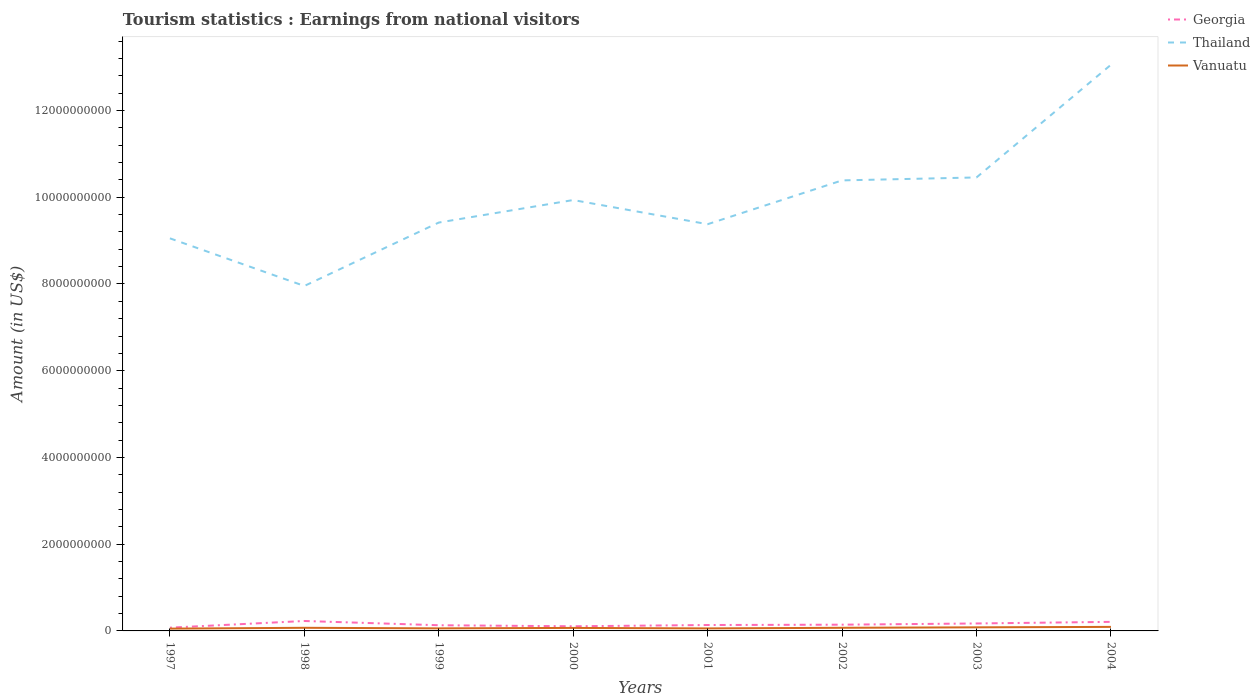How many different coloured lines are there?
Provide a succinct answer. 3. Across all years, what is the maximum earnings from national visitors in Thailand?
Provide a short and direct response. 7.95e+09. In which year was the earnings from national visitors in Vanuatu maximum?
Your answer should be very brief. 1997. What is the total earnings from national visitors in Georgia in the graph?
Your answer should be compact. -8.00e+06. What is the difference between the highest and the second highest earnings from national visitors in Georgia?
Make the answer very short. 1.54e+08. What is the difference between the highest and the lowest earnings from national visitors in Georgia?
Provide a succinct answer. 3. How many lines are there?
Provide a succinct answer. 3. How many years are there in the graph?
Provide a short and direct response. 8. Does the graph contain any zero values?
Ensure brevity in your answer.  No. Where does the legend appear in the graph?
Make the answer very short. Top right. How are the legend labels stacked?
Your response must be concise. Vertical. What is the title of the graph?
Your answer should be very brief. Tourism statistics : Earnings from national visitors. Does "Djibouti" appear as one of the legend labels in the graph?
Ensure brevity in your answer.  No. What is the Amount (in US$) of Georgia in 1997?
Offer a terse response. 7.50e+07. What is the Amount (in US$) of Thailand in 1997?
Your answer should be very brief. 9.05e+09. What is the Amount (in US$) of Vanuatu in 1997?
Offer a very short reply. 5.30e+07. What is the Amount (in US$) of Georgia in 1998?
Your response must be concise. 2.29e+08. What is the Amount (in US$) in Thailand in 1998?
Your answer should be very brief. 7.95e+09. What is the Amount (in US$) in Vanuatu in 1998?
Ensure brevity in your answer.  7.20e+07. What is the Amount (in US$) in Georgia in 1999?
Your answer should be compact. 1.31e+08. What is the Amount (in US$) of Thailand in 1999?
Offer a very short reply. 9.42e+09. What is the Amount (in US$) of Vanuatu in 1999?
Give a very brief answer. 5.90e+07. What is the Amount (in US$) in Georgia in 2000?
Provide a short and direct response. 1.07e+08. What is the Amount (in US$) of Thailand in 2000?
Make the answer very short. 9.94e+09. What is the Amount (in US$) in Vanuatu in 2000?
Your response must be concise. 6.90e+07. What is the Amount (in US$) of Georgia in 2001?
Offer a terse response. 1.36e+08. What is the Amount (in US$) of Thailand in 2001?
Keep it short and to the point. 9.38e+09. What is the Amount (in US$) of Vanuatu in 2001?
Give a very brief answer. 5.80e+07. What is the Amount (in US$) in Georgia in 2002?
Ensure brevity in your answer.  1.44e+08. What is the Amount (in US$) of Thailand in 2002?
Your answer should be compact. 1.04e+1. What is the Amount (in US$) in Vanuatu in 2002?
Your answer should be compact. 7.20e+07. What is the Amount (in US$) in Georgia in 2003?
Provide a succinct answer. 1.72e+08. What is the Amount (in US$) in Thailand in 2003?
Give a very brief answer. 1.05e+1. What is the Amount (in US$) in Vanuatu in 2003?
Provide a short and direct response. 8.30e+07. What is the Amount (in US$) of Georgia in 2004?
Provide a succinct answer. 2.09e+08. What is the Amount (in US$) in Thailand in 2004?
Your answer should be compact. 1.31e+1. What is the Amount (in US$) of Vanuatu in 2004?
Your answer should be very brief. 9.30e+07. Across all years, what is the maximum Amount (in US$) of Georgia?
Provide a succinct answer. 2.29e+08. Across all years, what is the maximum Amount (in US$) in Thailand?
Give a very brief answer. 1.31e+1. Across all years, what is the maximum Amount (in US$) in Vanuatu?
Offer a very short reply. 9.30e+07. Across all years, what is the minimum Amount (in US$) of Georgia?
Ensure brevity in your answer.  7.50e+07. Across all years, what is the minimum Amount (in US$) in Thailand?
Keep it short and to the point. 7.95e+09. Across all years, what is the minimum Amount (in US$) in Vanuatu?
Your answer should be compact. 5.30e+07. What is the total Amount (in US$) of Georgia in the graph?
Give a very brief answer. 1.20e+09. What is the total Amount (in US$) in Thailand in the graph?
Give a very brief answer. 7.96e+1. What is the total Amount (in US$) in Vanuatu in the graph?
Make the answer very short. 5.59e+08. What is the difference between the Amount (in US$) in Georgia in 1997 and that in 1998?
Make the answer very short. -1.54e+08. What is the difference between the Amount (in US$) in Thailand in 1997 and that in 1998?
Your answer should be very brief. 1.10e+09. What is the difference between the Amount (in US$) in Vanuatu in 1997 and that in 1998?
Your response must be concise. -1.90e+07. What is the difference between the Amount (in US$) in Georgia in 1997 and that in 1999?
Your response must be concise. -5.60e+07. What is the difference between the Amount (in US$) of Thailand in 1997 and that in 1999?
Provide a succinct answer. -3.64e+08. What is the difference between the Amount (in US$) of Vanuatu in 1997 and that in 1999?
Keep it short and to the point. -6.00e+06. What is the difference between the Amount (in US$) in Georgia in 1997 and that in 2000?
Offer a very short reply. -3.20e+07. What is the difference between the Amount (in US$) in Thailand in 1997 and that in 2000?
Ensure brevity in your answer.  -8.83e+08. What is the difference between the Amount (in US$) of Vanuatu in 1997 and that in 2000?
Offer a terse response. -1.60e+07. What is the difference between the Amount (in US$) of Georgia in 1997 and that in 2001?
Provide a short and direct response. -6.10e+07. What is the difference between the Amount (in US$) of Thailand in 1997 and that in 2001?
Provide a short and direct response. -3.26e+08. What is the difference between the Amount (in US$) in Vanuatu in 1997 and that in 2001?
Your answer should be very brief. -5.00e+06. What is the difference between the Amount (in US$) in Georgia in 1997 and that in 2002?
Your answer should be compact. -6.90e+07. What is the difference between the Amount (in US$) of Thailand in 1997 and that in 2002?
Your answer should be compact. -1.34e+09. What is the difference between the Amount (in US$) of Vanuatu in 1997 and that in 2002?
Your response must be concise. -1.90e+07. What is the difference between the Amount (in US$) in Georgia in 1997 and that in 2003?
Your answer should be compact. -9.70e+07. What is the difference between the Amount (in US$) of Thailand in 1997 and that in 2003?
Provide a succinct answer. -1.40e+09. What is the difference between the Amount (in US$) of Vanuatu in 1997 and that in 2003?
Offer a terse response. -3.00e+07. What is the difference between the Amount (in US$) of Georgia in 1997 and that in 2004?
Your response must be concise. -1.34e+08. What is the difference between the Amount (in US$) of Thailand in 1997 and that in 2004?
Your answer should be very brief. -4.00e+09. What is the difference between the Amount (in US$) in Vanuatu in 1997 and that in 2004?
Provide a short and direct response. -4.00e+07. What is the difference between the Amount (in US$) in Georgia in 1998 and that in 1999?
Your answer should be very brief. 9.80e+07. What is the difference between the Amount (in US$) in Thailand in 1998 and that in 1999?
Ensure brevity in your answer.  -1.46e+09. What is the difference between the Amount (in US$) in Vanuatu in 1998 and that in 1999?
Your answer should be very brief. 1.30e+07. What is the difference between the Amount (in US$) in Georgia in 1998 and that in 2000?
Provide a short and direct response. 1.22e+08. What is the difference between the Amount (in US$) of Thailand in 1998 and that in 2000?
Offer a very short reply. -1.98e+09. What is the difference between the Amount (in US$) of Georgia in 1998 and that in 2001?
Offer a very short reply. 9.30e+07. What is the difference between the Amount (in US$) in Thailand in 1998 and that in 2001?
Make the answer very short. -1.42e+09. What is the difference between the Amount (in US$) of Vanuatu in 1998 and that in 2001?
Give a very brief answer. 1.40e+07. What is the difference between the Amount (in US$) of Georgia in 1998 and that in 2002?
Your response must be concise. 8.50e+07. What is the difference between the Amount (in US$) of Thailand in 1998 and that in 2002?
Keep it short and to the point. -2.43e+09. What is the difference between the Amount (in US$) of Georgia in 1998 and that in 2003?
Offer a terse response. 5.70e+07. What is the difference between the Amount (in US$) of Thailand in 1998 and that in 2003?
Make the answer very short. -2.50e+09. What is the difference between the Amount (in US$) of Vanuatu in 1998 and that in 2003?
Your answer should be compact. -1.10e+07. What is the difference between the Amount (in US$) in Georgia in 1998 and that in 2004?
Provide a succinct answer. 2.00e+07. What is the difference between the Amount (in US$) in Thailand in 1998 and that in 2004?
Your answer should be compact. -5.10e+09. What is the difference between the Amount (in US$) of Vanuatu in 1998 and that in 2004?
Provide a short and direct response. -2.10e+07. What is the difference between the Amount (in US$) of Georgia in 1999 and that in 2000?
Offer a very short reply. 2.40e+07. What is the difference between the Amount (in US$) of Thailand in 1999 and that in 2000?
Give a very brief answer. -5.19e+08. What is the difference between the Amount (in US$) in Vanuatu in 1999 and that in 2000?
Offer a terse response. -1.00e+07. What is the difference between the Amount (in US$) of Georgia in 1999 and that in 2001?
Your answer should be compact. -5.00e+06. What is the difference between the Amount (in US$) in Thailand in 1999 and that in 2001?
Your response must be concise. 3.80e+07. What is the difference between the Amount (in US$) of Georgia in 1999 and that in 2002?
Give a very brief answer. -1.30e+07. What is the difference between the Amount (in US$) of Thailand in 1999 and that in 2002?
Keep it short and to the point. -9.72e+08. What is the difference between the Amount (in US$) of Vanuatu in 1999 and that in 2002?
Give a very brief answer. -1.30e+07. What is the difference between the Amount (in US$) of Georgia in 1999 and that in 2003?
Keep it short and to the point. -4.10e+07. What is the difference between the Amount (in US$) of Thailand in 1999 and that in 2003?
Make the answer very short. -1.04e+09. What is the difference between the Amount (in US$) of Vanuatu in 1999 and that in 2003?
Give a very brief answer. -2.40e+07. What is the difference between the Amount (in US$) of Georgia in 1999 and that in 2004?
Give a very brief answer. -7.80e+07. What is the difference between the Amount (in US$) in Thailand in 1999 and that in 2004?
Give a very brief answer. -3.64e+09. What is the difference between the Amount (in US$) in Vanuatu in 1999 and that in 2004?
Provide a short and direct response. -3.40e+07. What is the difference between the Amount (in US$) in Georgia in 2000 and that in 2001?
Offer a terse response. -2.90e+07. What is the difference between the Amount (in US$) of Thailand in 2000 and that in 2001?
Ensure brevity in your answer.  5.57e+08. What is the difference between the Amount (in US$) of Vanuatu in 2000 and that in 2001?
Your answer should be compact. 1.10e+07. What is the difference between the Amount (in US$) in Georgia in 2000 and that in 2002?
Provide a succinct answer. -3.70e+07. What is the difference between the Amount (in US$) of Thailand in 2000 and that in 2002?
Keep it short and to the point. -4.53e+08. What is the difference between the Amount (in US$) of Vanuatu in 2000 and that in 2002?
Your answer should be very brief. -3.00e+06. What is the difference between the Amount (in US$) in Georgia in 2000 and that in 2003?
Provide a succinct answer. -6.50e+07. What is the difference between the Amount (in US$) in Thailand in 2000 and that in 2003?
Your answer should be compact. -5.21e+08. What is the difference between the Amount (in US$) of Vanuatu in 2000 and that in 2003?
Your response must be concise. -1.40e+07. What is the difference between the Amount (in US$) of Georgia in 2000 and that in 2004?
Keep it short and to the point. -1.02e+08. What is the difference between the Amount (in US$) in Thailand in 2000 and that in 2004?
Keep it short and to the point. -3.12e+09. What is the difference between the Amount (in US$) of Vanuatu in 2000 and that in 2004?
Offer a terse response. -2.40e+07. What is the difference between the Amount (in US$) in Georgia in 2001 and that in 2002?
Offer a very short reply. -8.00e+06. What is the difference between the Amount (in US$) of Thailand in 2001 and that in 2002?
Your answer should be compact. -1.01e+09. What is the difference between the Amount (in US$) of Vanuatu in 2001 and that in 2002?
Ensure brevity in your answer.  -1.40e+07. What is the difference between the Amount (in US$) in Georgia in 2001 and that in 2003?
Offer a terse response. -3.60e+07. What is the difference between the Amount (in US$) in Thailand in 2001 and that in 2003?
Give a very brief answer. -1.08e+09. What is the difference between the Amount (in US$) in Vanuatu in 2001 and that in 2003?
Ensure brevity in your answer.  -2.50e+07. What is the difference between the Amount (in US$) in Georgia in 2001 and that in 2004?
Ensure brevity in your answer.  -7.30e+07. What is the difference between the Amount (in US$) of Thailand in 2001 and that in 2004?
Keep it short and to the point. -3.68e+09. What is the difference between the Amount (in US$) in Vanuatu in 2001 and that in 2004?
Make the answer very short. -3.50e+07. What is the difference between the Amount (in US$) in Georgia in 2002 and that in 2003?
Offer a very short reply. -2.80e+07. What is the difference between the Amount (in US$) in Thailand in 2002 and that in 2003?
Give a very brief answer. -6.80e+07. What is the difference between the Amount (in US$) in Vanuatu in 2002 and that in 2003?
Keep it short and to the point. -1.10e+07. What is the difference between the Amount (in US$) in Georgia in 2002 and that in 2004?
Provide a short and direct response. -6.50e+07. What is the difference between the Amount (in US$) in Thailand in 2002 and that in 2004?
Give a very brief answer. -2.67e+09. What is the difference between the Amount (in US$) in Vanuatu in 2002 and that in 2004?
Ensure brevity in your answer.  -2.10e+07. What is the difference between the Amount (in US$) of Georgia in 2003 and that in 2004?
Your answer should be very brief. -3.70e+07. What is the difference between the Amount (in US$) in Thailand in 2003 and that in 2004?
Make the answer very short. -2.60e+09. What is the difference between the Amount (in US$) of Vanuatu in 2003 and that in 2004?
Your answer should be very brief. -1.00e+07. What is the difference between the Amount (in US$) of Georgia in 1997 and the Amount (in US$) of Thailand in 1998?
Offer a terse response. -7.88e+09. What is the difference between the Amount (in US$) in Thailand in 1997 and the Amount (in US$) in Vanuatu in 1998?
Give a very brief answer. 8.98e+09. What is the difference between the Amount (in US$) of Georgia in 1997 and the Amount (in US$) of Thailand in 1999?
Offer a terse response. -9.34e+09. What is the difference between the Amount (in US$) in Georgia in 1997 and the Amount (in US$) in Vanuatu in 1999?
Give a very brief answer. 1.60e+07. What is the difference between the Amount (in US$) in Thailand in 1997 and the Amount (in US$) in Vanuatu in 1999?
Your answer should be very brief. 8.99e+09. What is the difference between the Amount (in US$) of Georgia in 1997 and the Amount (in US$) of Thailand in 2000?
Keep it short and to the point. -9.86e+09. What is the difference between the Amount (in US$) of Thailand in 1997 and the Amount (in US$) of Vanuatu in 2000?
Make the answer very short. 8.98e+09. What is the difference between the Amount (in US$) of Georgia in 1997 and the Amount (in US$) of Thailand in 2001?
Your answer should be compact. -9.30e+09. What is the difference between the Amount (in US$) in Georgia in 1997 and the Amount (in US$) in Vanuatu in 2001?
Offer a terse response. 1.70e+07. What is the difference between the Amount (in US$) of Thailand in 1997 and the Amount (in US$) of Vanuatu in 2001?
Your answer should be very brief. 8.99e+09. What is the difference between the Amount (in US$) of Georgia in 1997 and the Amount (in US$) of Thailand in 2002?
Offer a very short reply. -1.03e+1. What is the difference between the Amount (in US$) in Thailand in 1997 and the Amount (in US$) in Vanuatu in 2002?
Offer a very short reply. 8.98e+09. What is the difference between the Amount (in US$) in Georgia in 1997 and the Amount (in US$) in Thailand in 2003?
Ensure brevity in your answer.  -1.04e+1. What is the difference between the Amount (in US$) of Georgia in 1997 and the Amount (in US$) of Vanuatu in 2003?
Make the answer very short. -8.00e+06. What is the difference between the Amount (in US$) of Thailand in 1997 and the Amount (in US$) of Vanuatu in 2003?
Keep it short and to the point. 8.97e+09. What is the difference between the Amount (in US$) in Georgia in 1997 and the Amount (in US$) in Thailand in 2004?
Your answer should be compact. -1.30e+1. What is the difference between the Amount (in US$) of Georgia in 1997 and the Amount (in US$) of Vanuatu in 2004?
Your answer should be compact. -1.80e+07. What is the difference between the Amount (in US$) in Thailand in 1997 and the Amount (in US$) in Vanuatu in 2004?
Give a very brief answer. 8.96e+09. What is the difference between the Amount (in US$) in Georgia in 1998 and the Amount (in US$) in Thailand in 1999?
Your response must be concise. -9.19e+09. What is the difference between the Amount (in US$) of Georgia in 1998 and the Amount (in US$) of Vanuatu in 1999?
Provide a succinct answer. 1.70e+08. What is the difference between the Amount (in US$) in Thailand in 1998 and the Amount (in US$) in Vanuatu in 1999?
Make the answer very short. 7.90e+09. What is the difference between the Amount (in US$) in Georgia in 1998 and the Amount (in US$) in Thailand in 2000?
Ensure brevity in your answer.  -9.71e+09. What is the difference between the Amount (in US$) in Georgia in 1998 and the Amount (in US$) in Vanuatu in 2000?
Make the answer very short. 1.60e+08. What is the difference between the Amount (in US$) of Thailand in 1998 and the Amount (in US$) of Vanuatu in 2000?
Keep it short and to the point. 7.88e+09. What is the difference between the Amount (in US$) in Georgia in 1998 and the Amount (in US$) in Thailand in 2001?
Provide a succinct answer. -9.15e+09. What is the difference between the Amount (in US$) of Georgia in 1998 and the Amount (in US$) of Vanuatu in 2001?
Your response must be concise. 1.71e+08. What is the difference between the Amount (in US$) of Thailand in 1998 and the Amount (in US$) of Vanuatu in 2001?
Offer a very short reply. 7.90e+09. What is the difference between the Amount (in US$) in Georgia in 1998 and the Amount (in US$) in Thailand in 2002?
Give a very brief answer. -1.02e+1. What is the difference between the Amount (in US$) of Georgia in 1998 and the Amount (in US$) of Vanuatu in 2002?
Make the answer very short. 1.57e+08. What is the difference between the Amount (in US$) of Thailand in 1998 and the Amount (in US$) of Vanuatu in 2002?
Your answer should be compact. 7.88e+09. What is the difference between the Amount (in US$) in Georgia in 1998 and the Amount (in US$) in Thailand in 2003?
Your response must be concise. -1.02e+1. What is the difference between the Amount (in US$) of Georgia in 1998 and the Amount (in US$) of Vanuatu in 2003?
Ensure brevity in your answer.  1.46e+08. What is the difference between the Amount (in US$) of Thailand in 1998 and the Amount (in US$) of Vanuatu in 2003?
Provide a succinct answer. 7.87e+09. What is the difference between the Amount (in US$) in Georgia in 1998 and the Amount (in US$) in Thailand in 2004?
Keep it short and to the point. -1.28e+1. What is the difference between the Amount (in US$) of Georgia in 1998 and the Amount (in US$) of Vanuatu in 2004?
Make the answer very short. 1.36e+08. What is the difference between the Amount (in US$) of Thailand in 1998 and the Amount (in US$) of Vanuatu in 2004?
Give a very brief answer. 7.86e+09. What is the difference between the Amount (in US$) of Georgia in 1999 and the Amount (in US$) of Thailand in 2000?
Ensure brevity in your answer.  -9.80e+09. What is the difference between the Amount (in US$) in Georgia in 1999 and the Amount (in US$) in Vanuatu in 2000?
Offer a very short reply. 6.20e+07. What is the difference between the Amount (in US$) in Thailand in 1999 and the Amount (in US$) in Vanuatu in 2000?
Offer a very short reply. 9.35e+09. What is the difference between the Amount (in US$) in Georgia in 1999 and the Amount (in US$) in Thailand in 2001?
Offer a very short reply. -9.25e+09. What is the difference between the Amount (in US$) in Georgia in 1999 and the Amount (in US$) in Vanuatu in 2001?
Provide a short and direct response. 7.30e+07. What is the difference between the Amount (in US$) in Thailand in 1999 and the Amount (in US$) in Vanuatu in 2001?
Provide a short and direct response. 9.36e+09. What is the difference between the Amount (in US$) of Georgia in 1999 and the Amount (in US$) of Thailand in 2002?
Your answer should be very brief. -1.03e+1. What is the difference between the Amount (in US$) of Georgia in 1999 and the Amount (in US$) of Vanuatu in 2002?
Give a very brief answer. 5.90e+07. What is the difference between the Amount (in US$) of Thailand in 1999 and the Amount (in US$) of Vanuatu in 2002?
Your response must be concise. 9.34e+09. What is the difference between the Amount (in US$) in Georgia in 1999 and the Amount (in US$) in Thailand in 2003?
Keep it short and to the point. -1.03e+1. What is the difference between the Amount (in US$) in Georgia in 1999 and the Amount (in US$) in Vanuatu in 2003?
Give a very brief answer. 4.80e+07. What is the difference between the Amount (in US$) of Thailand in 1999 and the Amount (in US$) of Vanuatu in 2003?
Your answer should be compact. 9.33e+09. What is the difference between the Amount (in US$) of Georgia in 1999 and the Amount (in US$) of Thailand in 2004?
Keep it short and to the point. -1.29e+1. What is the difference between the Amount (in US$) in Georgia in 1999 and the Amount (in US$) in Vanuatu in 2004?
Make the answer very short. 3.80e+07. What is the difference between the Amount (in US$) of Thailand in 1999 and the Amount (in US$) of Vanuatu in 2004?
Offer a very short reply. 9.32e+09. What is the difference between the Amount (in US$) of Georgia in 2000 and the Amount (in US$) of Thailand in 2001?
Offer a terse response. -9.27e+09. What is the difference between the Amount (in US$) in Georgia in 2000 and the Amount (in US$) in Vanuatu in 2001?
Ensure brevity in your answer.  4.90e+07. What is the difference between the Amount (in US$) in Thailand in 2000 and the Amount (in US$) in Vanuatu in 2001?
Offer a very short reply. 9.88e+09. What is the difference between the Amount (in US$) of Georgia in 2000 and the Amount (in US$) of Thailand in 2002?
Your answer should be compact. -1.03e+1. What is the difference between the Amount (in US$) of Georgia in 2000 and the Amount (in US$) of Vanuatu in 2002?
Offer a terse response. 3.50e+07. What is the difference between the Amount (in US$) in Thailand in 2000 and the Amount (in US$) in Vanuatu in 2002?
Your answer should be very brief. 9.86e+09. What is the difference between the Amount (in US$) in Georgia in 2000 and the Amount (in US$) in Thailand in 2003?
Your answer should be compact. -1.03e+1. What is the difference between the Amount (in US$) in Georgia in 2000 and the Amount (in US$) in Vanuatu in 2003?
Your answer should be compact. 2.40e+07. What is the difference between the Amount (in US$) in Thailand in 2000 and the Amount (in US$) in Vanuatu in 2003?
Keep it short and to the point. 9.85e+09. What is the difference between the Amount (in US$) of Georgia in 2000 and the Amount (in US$) of Thailand in 2004?
Your response must be concise. -1.29e+1. What is the difference between the Amount (in US$) in Georgia in 2000 and the Amount (in US$) in Vanuatu in 2004?
Provide a succinct answer. 1.40e+07. What is the difference between the Amount (in US$) in Thailand in 2000 and the Amount (in US$) in Vanuatu in 2004?
Your answer should be compact. 9.84e+09. What is the difference between the Amount (in US$) in Georgia in 2001 and the Amount (in US$) in Thailand in 2002?
Offer a terse response. -1.03e+1. What is the difference between the Amount (in US$) in Georgia in 2001 and the Amount (in US$) in Vanuatu in 2002?
Offer a very short reply. 6.40e+07. What is the difference between the Amount (in US$) of Thailand in 2001 and the Amount (in US$) of Vanuatu in 2002?
Provide a succinct answer. 9.31e+09. What is the difference between the Amount (in US$) in Georgia in 2001 and the Amount (in US$) in Thailand in 2003?
Your response must be concise. -1.03e+1. What is the difference between the Amount (in US$) of Georgia in 2001 and the Amount (in US$) of Vanuatu in 2003?
Your answer should be compact. 5.30e+07. What is the difference between the Amount (in US$) in Thailand in 2001 and the Amount (in US$) in Vanuatu in 2003?
Your answer should be compact. 9.30e+09. What is the difference between the Amount (in US$) of Georgia in 2001 and the Amount (in US$) of Thailand in 2004?
Ensure brevity in your answer.  -1.29e+1. What is the difference between the Amount (in US$) in Georgia in 2001 and the Amount (in US$) in Vanuatu in 2004?
Ensure brevity in your answer.  4.30e+07. What is the difference between the Amount (in US$) in Thailand in 2001 and the Amount (in US$) in Vanuatu in 2004?
Ensure brevity in your answer.  9.28e+09. What is the difference between the Amount (in US$) in Georgia in 2002 and the Amount (in US$) in Thailand in 2003?
Give a very brief answer. -1.03e+1. What is the difference between the Amount (in US$) in Georgia in 2002 and the Amount (in US$) in Vanuatu in 2003?
Make the answer very short. 6.10e+07. What is the difference between the Amount (in US$) of Thailand in 2002 and the Amount (in US$) of Vanuatu in 2003?
Offer a terse response. 1.03e+1. What is the difference between the Amount (in US$) of Georgia in 2002 and the Amount (in US$) of Thailand in 2004?
Offer a very short reply. -1.29e+1. What is the difference between the Amount (in US$) in Georgia in 2002 and the Amount (in US$) in Vanuatu in 2004?
Keep it short and to the point. 5.10e+07. What is the difference between the Amount (in US$) of Thailand in 2002 and the Amount (in US$) of Vanuatu in 2004?
Offer a very short reply. 1.03e+1. What is the difference between the Amount (in US$) in Georgia in 2003 and the Amount (in US$) in Thailand in 2004?
Offer a very short reply. -1.29e+1. What is the difference between the Amount (in US$) in Georgia in 2003 and the Amount (in US$) in Vanuatu in 2004?
Offer a terse response. 7.90e+07. What is the difference between the Amount (in US$) of Thailand in 2003 and the Amount (in US$) of Vanuatu in 2004?
Your answer should be very brief. 1.04e+1. What is the average Amount (in US$) in Georgia per year?
Provide a succinct answer. 1.50e+08. What is the average Amount (in US$) in Thailand per year?
Make the answer very short. 9.95e+09. What is the average Amount (in US$) of Vanuatu per year?
Ensure brevity in your answer.  6.99e+07. In the year 1997, what is the difference between the Amount (in US$) in Georgia and Amount (in US$) in Thailand?
Provide a short and direct response. -8.98e+09. In the year 1997, what is the difference between the Amount (in US$) of Georgia and Amount (in US$) of Vanuatu?
Give a very brief answer. 2.20e+07. In the year 1997, what is the difference between the Amount (in US$) of Thailand and Amount (in US$) of Vanuatu?
Make the answer very short. 9.00e+09. In the year 1998, what is the difference between the Amount (in US$) in Georgia and Amount (in US$) in Thailand?
Your answer should be very brief. -7.72e+09. In the year 1998, what is the difference between the Amount (in US$) of Georgia and Amount (in US$) of Vanuatu?
Offer a very short reply. 1.57e+08. In the year 1998, what is the difference between the Amount (in US$) of Thailand and Amount (in US$) of Vanuatu?
Offer a very short reply. 7.88e+09. In the year 1999, what is the difference between the Amount (in US$) in Georgia and Amount (in US$) in Thailand?
Provide a short and direct response. -9.28e+09. In the year 1999, what is the difference between the Amount (in US$) of Georgia and Amount (in US$) of Vanuatu?
Provide a short and direct response. 7.20e+07. In the year 1999, what is the difference between the Amount (in US$) in Thailand and Amount (in US$) in Vanuatu?
Offer a terse response. 9.36e+09. In the year 2000, what is the difference between the Amount (in US$) in Georgia and Amount (in US$) in Thailand?
Your answer should be compact. -9.83e+09. In the year 2000, what is the difference between the Amount (in US$) of Georgia and Amount (in US$) of Vanuatu?
Provide a succinct answer. 3.80e+07. In the year 2000, what is the difference between the Amount (in US$) in Thailand and Amount (in US$) in Vanuatu?
Keep it short and to the point. 9.87e+09. In the year 2001, what is the difference between the Amount (in US$) in Georgia and Amount (in US$) in Thailand?
Offer a terse response. -9.24e+09. In the year 2001, what is the difference between the Amount (in US$) of Georgia and Amount (in US$) of Vanuatu?
Keep it short and to the point. 7.80e+07. In the year 2001, what is the difference between the Amount (in US$) of Thailand and Amount (in US$) of Vanuatu?
Your answer should be very brief. 9.32e+09. In the year 2002, what is the difference between the Amount (in US$) of Georgia and Amount (in US$) of Thailand?
Provide a succinct answer. -1.02e+1. In the year 2002, what is the difference between the Amount (in US$) in Georgia and Amount (in US$) in Vanuatu?
Keep it short and to the point. 7.20e+07. In the year 2002, what is the difference between the Amount (in US$) in Thailand and Amount (in US$) in Vanuatu?
Offer a terse response. 1.03e+1. In the year 2003, what is the difference between the Amount (in US$) of Georgia and Amount (in US$) of Thailand?
Provide a succinct answer. -1.03e+1. In the year 2003, what is the difference between the Amount (in US$) in Georgia and Amount (in US$) in Vanuatu?
Ensure brevity in your answer.  8.90e+07. In the year 2003, what is the difference between the Amount (in US$) in Thailand and Amount (in US$) in Vanuatu?
Your response must be concise. 1.04e+1. In the year 2004, what is the difference between the Amount (in US$) of Georgia and Amount (in US$) of Thailand?
Your response must be concise. -1.28e+1. In the year 2004, what is the difference between the Amount (in US$) of Georgia and Amount (in US$) of Vanuatu?
Keep it short and to the point. 1.16e+08. In the year 2004, what is the difference between the Amount (in US$) of Thailand and Amount (in US$) of Vanuatu?
Give a very brief answer. 1.30e+1. What is the ratio of the Amount (in US$) of Georgia in 1997 to that in 1998?
Provide a short and direct response. 0.33. What is the ratio of the Amount (in US$) in Thailand in 1997 to that in 1998?
Give a very brief answer. 1.14. What is the ratio of the Amount (in US$) of Vanuatu in 1997 to that in 1998?
Make the answer very short. 0.74. What is the ratio of the Amount (in US$) of Georgia in 1997 to that in 1999?
Provide a short and direct response. 0.57. What is the ratio of the Amount (in US$) in Thailand in 1997 to that in 1999?
Offer a very short reply. 0.96. What is the ratio of the Amount (in US$) of Vanuatu in 1997 to that in 1999?
Ensure brevity in your answer.  0.9. What is the ratio of the Amount (in US$) in Georgia in 1997 to that in 2000?
Make the answer very short. 0.7. What is the ratio of the Amount (in US$) in Thailand in 1997 to that in 2000?
Your answer should be very brief. 0.91. What is the ratio of the Amount (in US$) of Vanuatu in 1997 to that in 2000?
Offer a terse response. 0.77. What is the ratio of the Amount (in US$) of Georgia in 1997 to that in 2001?
Offer a terse response. 0.55. What is the ratio of the Amount (in US$) in Thailand in 1997 to that in 2001?
Ensure brevity in your answer.  0.97. What is the ratio of the Amount (in US$) of Vanuatu in 1997 to that in 2001?
Your answer should be very brief. 0.91. What is the ratio of the Amount (in US$) of Georgia in 1997 to that in 2002?
Give a very brief answer. 0.52. What is the ratio of the Amount (in US$) in Thailand in 1997 to that in 2002?
Give a very brief answer. 0.87. What is the ratio of the Amount (in US$) of Vanuatu in 1997 to that in 2002?
Your response must be concise. 0.74. What is the ratio of the Amount (in US$) in Georgia in 1997 to that in 2003?
Offer a terse response. 0.44. What is the ratio of the Amount (in US$) of Thailand in 1997 to that in 2003?
Keep it short and to the point. 0.87. What is the ratio of the Amount (in US$) of Vanuatu in 1997 to that in 2003?
Provide a short and direct response. 0.64. What is the ratio of the Amount (in US$) of Georgia in 1997 to that in 2004?
Ensure brevity in your answer.  0.36. What is the ratio of the Amount (in US$) of Thailand in 1997 to that in 2004?
Your answer should be compact. 0.69. What is the ratio of the Amount (in US$) of Vanuatu in 1997 to that in 2004?
Make the answer very short. 0.57. What is the ratio of the Amount (in US$) of Georgia in 1998 to that in 1999?
Your answer should be very brief. 1.75. What is the ratio of the Amount (in US$) of Thailand in 1998 to that in 1999?
Provide a succinct answer. 0.84. What is the ratio of the Amount (in US$) in Vanuatu in 1998 to that in 1999?
Your answer should be very brief. 1.22. What is the ratio of the Amount (in US$) of Georgia in 1998 to that in 2000?
Offer a very short reply. 2.14. What is the ratio of the Amount (in US$) in Thailand in 1998 to that in 2000?
Give a very brief answer. 0.8. What is the ratio of the Amount (in US$) of Vanuatu in 1998 to that in 2000?
Give a very brief answer. 1.04. What is the ratio of the Amount (in US$) in Georgia in 1998 to that in 2001?
Give a very brief answer. 1.68. What is the ratio of the Amount (in US$) of Thailand in 1998 to that in 2001?
Offer a terse response. 0.85. What is the ratio of the Amount (in US$) in Vanuatu in 1998 to that in 2001?
Ensure brevity in your answer.  1.24. What is the ratio of the Amount (in US$) in Georgia in 1998 to that in 2002?
Keep it short and to the point. 1.59. What is the ratio of the Amount (in US$) of Thailand in 1998 to that in 2002?
Provide a short and direct response. 0.77. What is the ratio of the Amount (in US$) of Vanuatu in 1998 to that in 2002?
Keep it short and to the point. 1. What is the ratio of the Amount (in US$) in Georgia in 1998 to that in 2003?
Give a very brief answer. 1.33. What is the ratio of the Amount (in US$) of Thailand in 1998 to that in 2003?
Your response must be concise. 0.76. What is the ratio of the Amount (in US$) of Vanuatu in 1998 to that in 2003?
Your answer should be compact. 0.87. What is the ratio of the Amount (in US$) in Georgia in 1998 to that in 2004?
Your answer should be compact. 1.1. What is the ratio of the Amount (in US$) in Thailand in 1998 to that in 2004?
Give a very brief answer. 0.61. What is the ratio of the Amount (in US$) in Vanuatu in 1998 to that in 2004?
Your answer should be very brief. 0.77. What is the ratio of the Amount (in US$) of Georgia in 1999 to that in 2000?
Your answer should be very brief. 1.22. What is the ratio of the Amount (in US$) in Thailand in 1999 to that in 2000?
Your answer should be very brief. 0.95. What is the ratio of the Amount (in US$) in Vanuatu in 1999 to that in 2000?
Offer a terse response. 0.86. What is the ratio of the Amount (in US$) in Georgia in 1999 to that in 2001?
Your answer should be compact. 0.96. What is the ratio of the Amount (in US$) in Thailand in 1999 to that in 2001?
Provide a succinct answer. 1. What is the ratio of the Amount (in US$) in Vanuatu in 1999 to that in 2001?
Provide a succinct answer. 1.02. What is the ratio of the Amount (in US$) of Georgia in 1999 to that in 2002?
Your answer should be compact. 0.91. What is the ratio of the Amount (in US$) of Thailand in 1999 to that in 2002?
Make the answer very short. 0.91. What is the ratio of the Amount (in US$) in Vanuatu in 1999 to that in 2002?
Provide a short and direct response. 0.82. What is the ratio of the Amount (in US$) of Georgia in 1999 to that in 2003?
Your response must be concise. 0.76. What is the ratio of the Amount (in US$) of Thailand in 1999 to that in 2003?
Offer a terse response. 0.9. What is the ratio of the Amount (in US$) in Vanuatu in 1999 to that in 2003?
Provide a succinct answer. 0.71. What is the ratio of the Amount (in US$) in Georgia in 1999 to that in 2004?
Offer a terse response. 0.63. What is the ratio of the Amount (in US$) in Thailand in 1999 to that in 2004?
Offer a very short reply. 0.72. What is the ratio of the Amount (in US$) in Vanuatu in 1999 to that in 2004?
Provide a succinct answer. 0.63. What is the ratio of the Amount (in US$) of Georgia in 2000 to that in 2001?
Your answer should be very brief. 0.79. What is the ratio of the Amount (in US$) of Thailand in 2000 to that in 2001?
Give a very brief answer. 1.06. What is the ratio of the Amount (in US$) of Vanuatu in 2000 to that in 2001?
Make the answer very short. 1.19. What is the ratio of the Amount (in US$) of Georgia in 2000 to that in 2002?
Offer a very short reply. 0.74. What is the ratio of the Amount (in US$) in Thailand in 2000 to that in 2002?
Your response must be concise. 0.96. What is the ratio of the Amount (in US$) in Vanuatu in 2000 to that in 2002?
Your answer should be compact. 0.96. What is the ratio of the Amount (in US$) of Georgia in 2000 to that in 2003?
Your response must be concise. 0.62. What is the ratio of the Amount (in US$) in Thailand in 2000 to that in 2003?
Your response must be concise. 0.95. What is the ratio of the Amount (in US$) of Vanuatu in 2000 to that in 2003?
Offer a terse response. 0.83. What is the ratio of the Amount (in US$) of Georgia in 2000 to that in 2004?
Your answer should be very brief. 0.51. What is the ratio of the Amount (in US$) of Thailand in 2000 to that in 2004?
Your answer should be very brief. 0.76. What is the ratio of the Amount (in US$) of Vanuatu in 2000 to that in 2004?
Offer a very short reply. 0.74. What is the ratio of the Amount (in US$) of Georgia in 2001 to that in 2002?
Make the answer very short. 0.94. What is the ratio of the Amount (in US$) of Thailand in 2001 to that in 2002?
Offer a terse response. 0.9. What is the ratio of the Amount (in US$) in Vanuatu in 2001 to that in 2002?
Give a very brief answer. 0.81. What is the ratio of the Amount (in US$) of Georgia in 2001 to that in 2003?
Give a very brief answer. 0.79. What is the ratio of the Amount (in US$) in Thailand in 2001 to that in 2003?
Offer a very short reply. 0.9. What is the ratio of the Amount (in US$) of Vanuatu in 2001 to that in 2003?
Provide a succinct answer. 0.7. What is the ratio of the Amount (in US$) of Georgia in 2001 to that in 2004?
Your answer should be very brief. 0.65. What is the ratio of the Amount (in US$) of Thailand in 2001 to that in 2004?
Ensure brevity in your answer.  0.72. What is the ratio of the Amount (in US$) in Vanuatu in 2001 to that in 2004?
Ensure brevity in your answer.  0.62. What is the ratio of the Amount (in US$) in Georgia in 2002 to that in 2003?
Your response must be concise. 0.84. What is the ratio of the Amount (in US$) of Vanuatu in 2002 to that in 2003?
Provide a succinct answer. 0.87. What is the ratio of the Amount (in US$) in Georgia in 2002 to that in 2004?
Your answer should be compact. 0.69. What is the ratio of the Amount (in US$) in Thailand in 2002 to that in 2004?
Provide a short and direct response. 0.8. What is the ratio of the Amount (in US$) in Vanuatu in 2002 to that in 2004?
Offer a terse response. 0.77. What is the ratio of the Amount (in US$) of Georgia in 2003 to that in 2004?
Offer a terse response. 0.82. What is the ratio of the Amount (in US$) in Thailand in 2003 to that in 2004?
Ensure brevity in your answer.  0.8. What is the ratio of the Amount (in US$) of Vanuatu in 2003 to that in 2004?
Give a very brief answer. 0.89. What is the difference between the highest and the second highest Amount (in US$) in Georgia?
Provide a succinct answer. 2.00e+07. What is the difference between the highest and the second highest Amount (in US$) of Thailand?
Provide a succinct answer. 2.60e+09. What is the difference between the highest and the lowest Amount (in US$) in Georgia?
Make the answer very short. 1.54e+08. What is the difference between the highest and the lowest Amount (in US$) in Thailand?
Provide a short and direct response. 5.10e+09. What is the difference between the highest and the lowest Amount (in US$) of Vanuatu?
Offer a very short reply. 4.00e+07. 